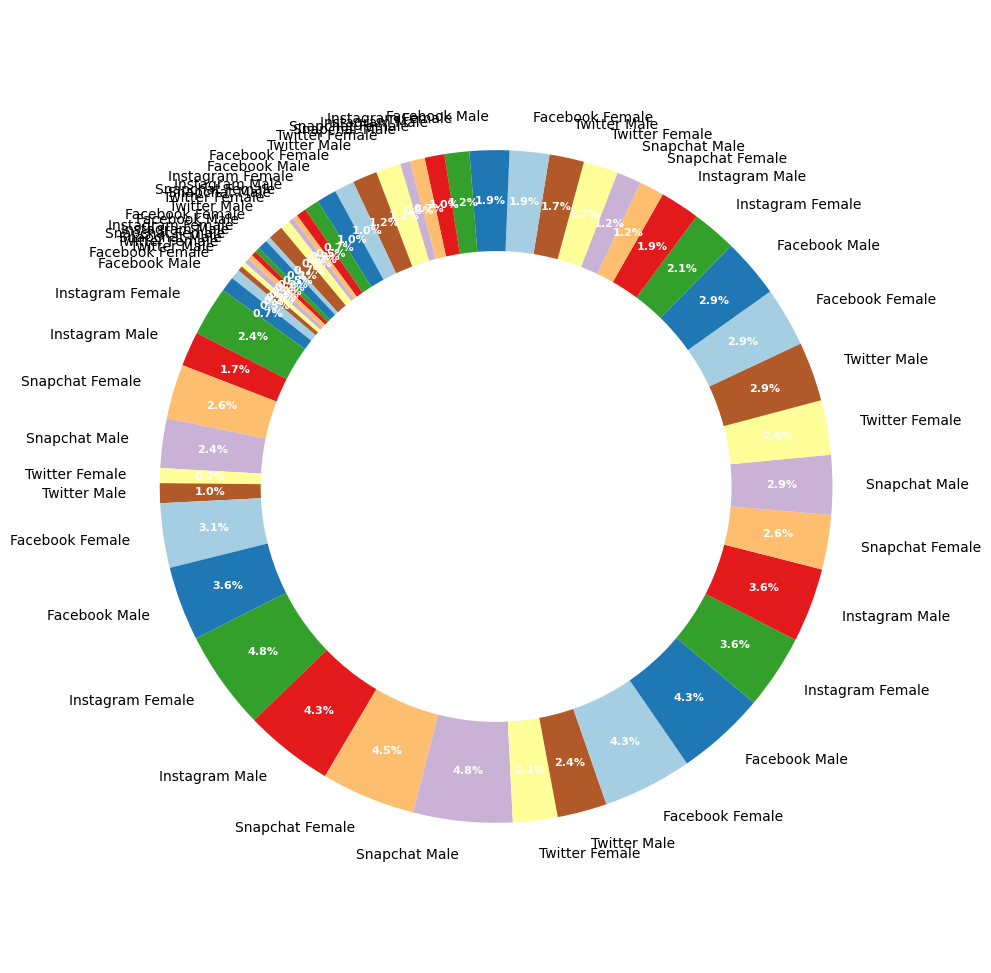What percentage of Facebook users are aged 25-34? Visually locate the segments labeled "25-34 Facebook Male" and "25-34 Facebook Female" on the ring chart and check the percentages for each. Sum the percentages for males and females in the 25-34 age group on Facebook: 18% (male) + 18% (female) = 36%.
Answer: 36% Do more females or males use Instagram in the 18-24 age group? Locate the segments for Instagram users aged 18-24 and compare the percentages: "18-24 Instagram Male" is 18% and "18-24 Instagram Female" is 20%. Since 20% > 18%, more females use Instagram in this age group.
Answer: Females Which platform has the highest percentage of female users aged 13-17? Compare the female segments across platforms for the 13-17 age group: Facebook (2%), Instagram (10%), Twitter (3%), Snapchat (11%). "Snapchat Female" with 11% is the highest.
Answer: Snapchat What is the combined percentage of Twitter users aged 35-44? Identify the segments for Twitter users aged 35-44 ("35-44 Twitter Male" and "35-44 Twitter Female") and sum their percentages: 7% (male) + 7% (female) = 14%.
Answer: 14% Among users aged 45-54, which platform has the smallest percentage of users? Compare the segments for users aged 45-54 across all platforms: Facebook (8% male + 8% female), Instagram (4% male + 5% female), Twitter (5% male + 5% female), Snapchat (2% male + 3% female). Snapchat has the smallest combined percentage: 5%.
Answer: Snapchat What is the ratio of male to female users of Snapchat aged 18-24? Locate the segments for Snapchat users aged 18-24 and identify the percentages: "18-24 Snapchat Male" is 20% and "18-24 Snapchat Female" is 19%. The ratio is 20:19.
Answer: 20:19 Which platform has the largest difference in user percentage between genders for the 13-17 age group? Check the differences between male and female percentages for each platform in the 13-17 age group: Facebook (3% - 2% = 1%), Instagram (10% - 7% = 3%), Twitter (4% - 3% = 1%), Snapchat (11% - 10% = 1%). Instagram has the largest difference of 3%.
Answer: Instagram On which platform do users aged 55-64 have the smallest representation overall? Sum the percentages of male and female users aged 55-64 for each platform: Facebook (4% + 4% = 8%), Instagram (2% + 3% = 5%), Twitter (3% + 2% = 5%), Snapchat (1% + 1% = 2%). Snapchat has the smallest representation overall with 2%.
Answer: Snapchat 